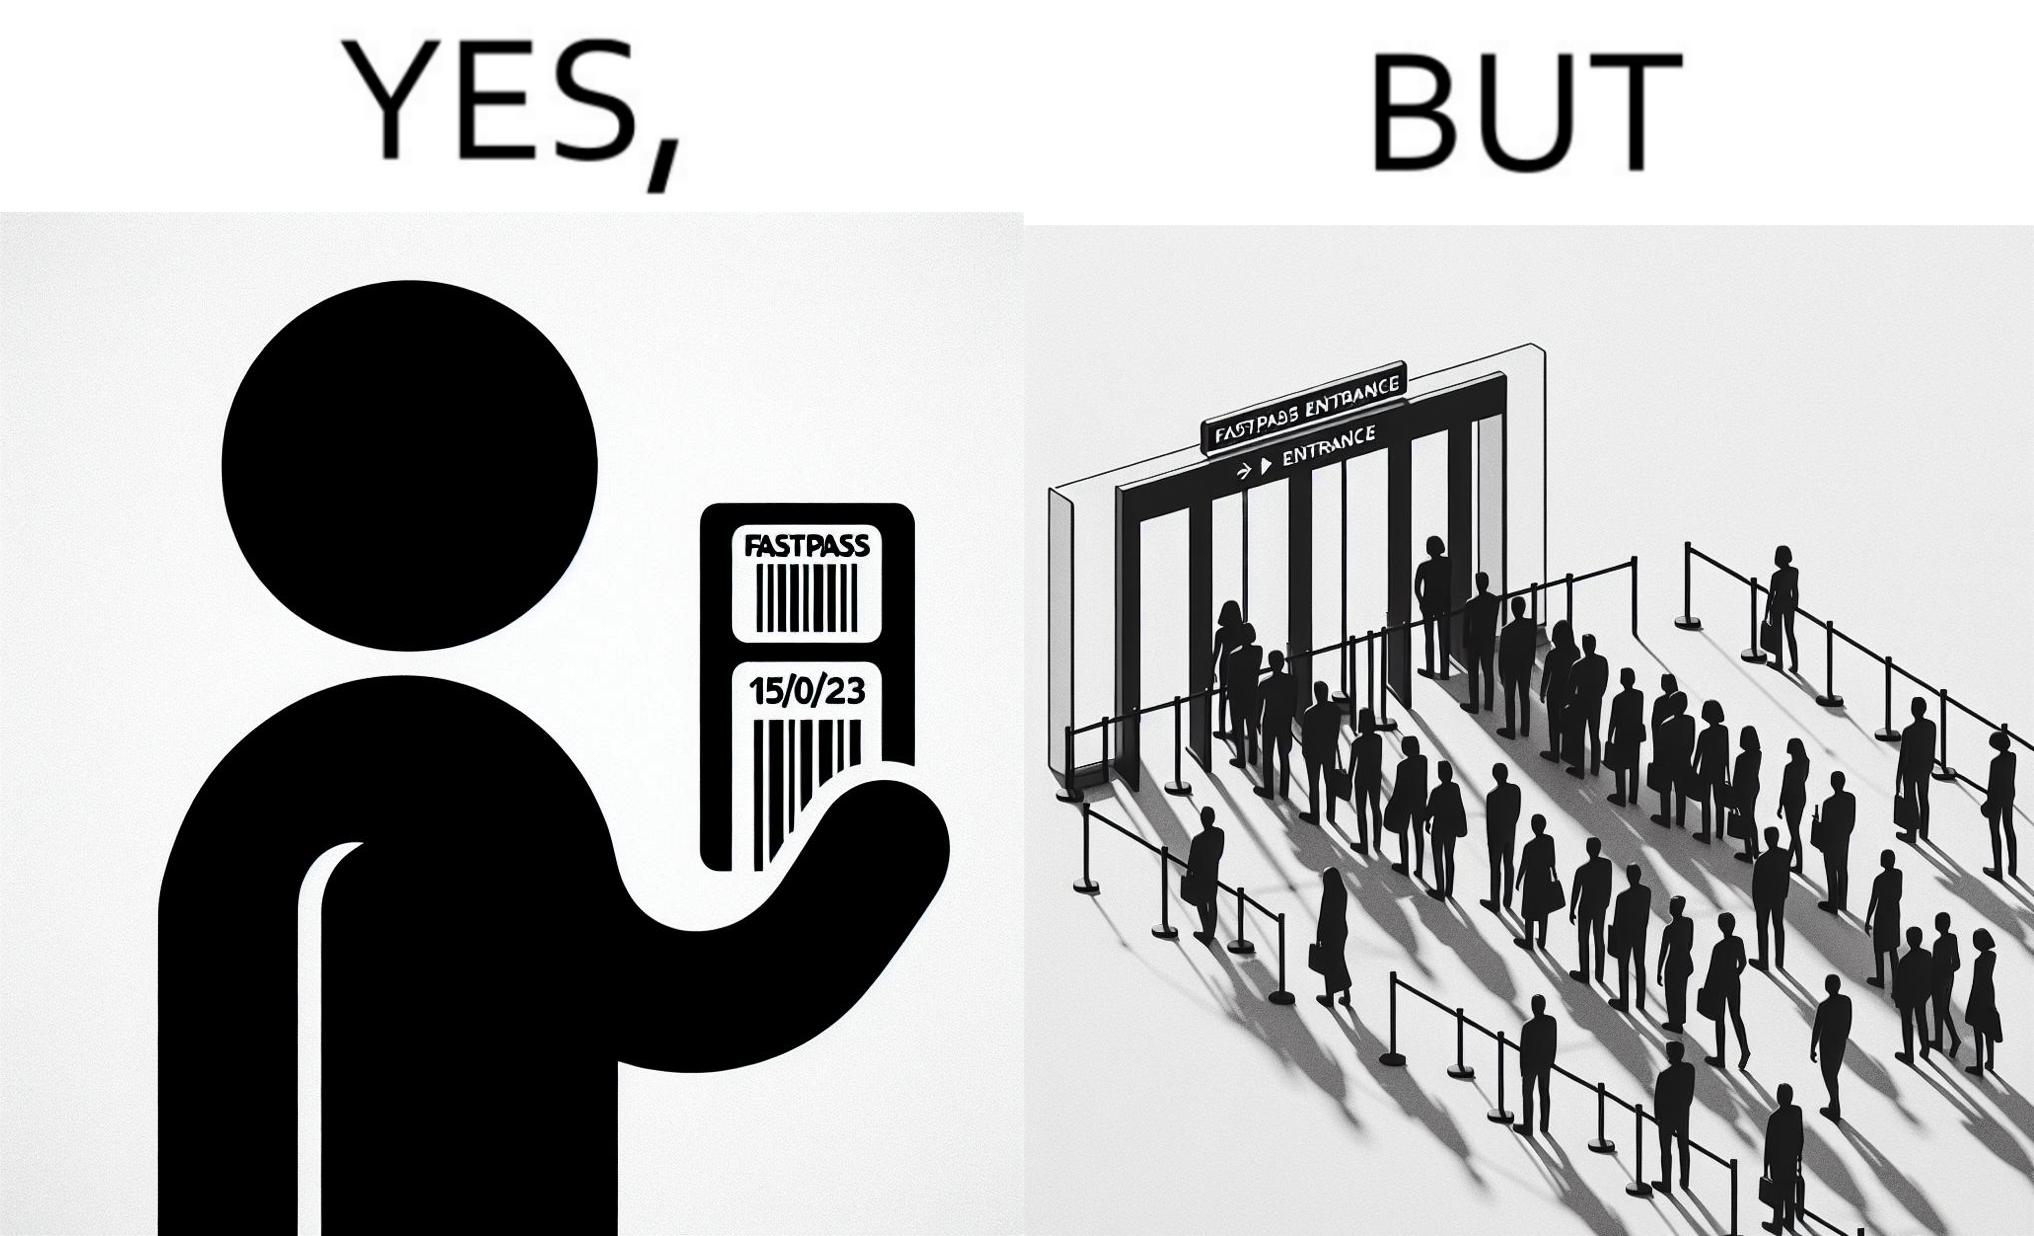Compare the left and right sides of this image. In the left part of the image: a person holding a "FASTPASS ENTRANCE" ticket or token of date "15/05/23" with some barcode In the right part of the image: people in a long queue in front of "FASTPASS ENTRANCE"  gate and "ENTRANCE" gate is vacant without any queue 